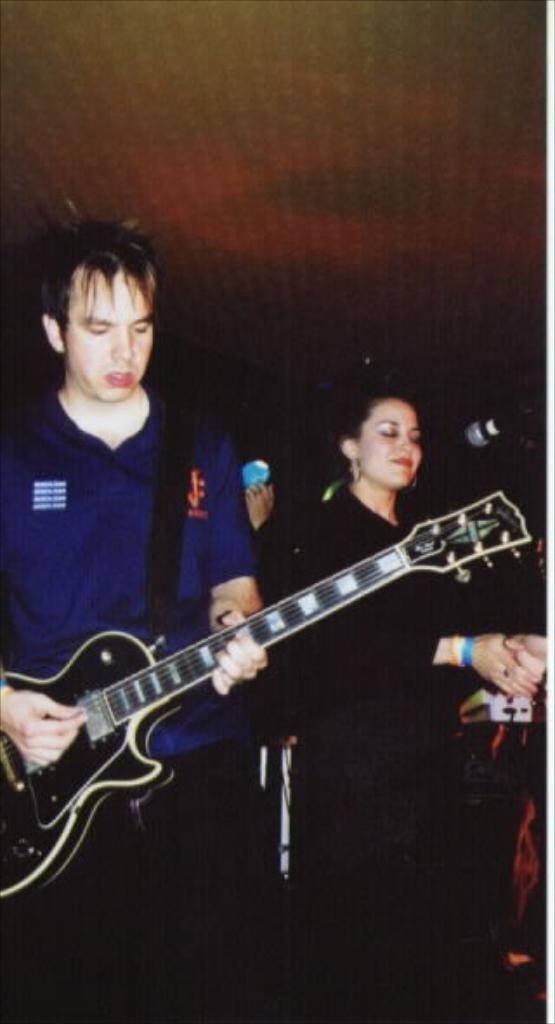How many people are in the image? There are two persons in the image. What are the positions of the persons in the image? Both persons are standing. What is one of the persons holding? One of the persons is holding a guitar. What type of design can be seen on the ladybug in the image? There is no ladybug present in the image. 